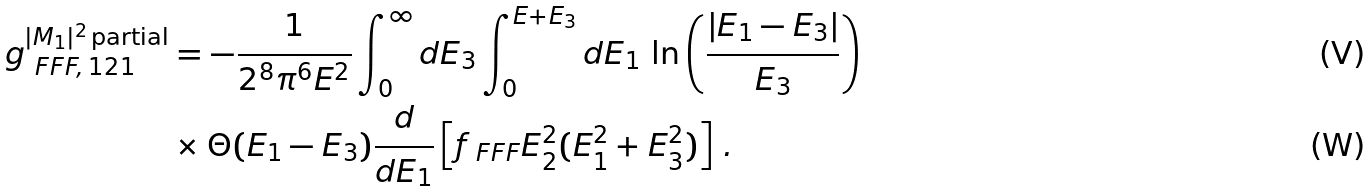Convert formula to latex. <formula><loc_0><loc_0><loc_500><loc_500>g _ { \ F F F , \, 1 2 1 } ^ { | M _ { 1 } | ^ { 2 } \, \text {partial} } & = - \frac { 1 } { 2 ^ { 8 } \pi ^ { 6 } E ^ { 2 } } \int _ { 0 } ^ { \infty } d E _ { 3 } \int _ { 0 } ^ { E + E _ { 3 } } d E _ { 1 } \, \ln \left ( \frac { | E _ { 1 } - E _ { 3 } | } { E _ { 3 } } \right ) \\ & \times \Theta ( E _ { 1 } - E _ { 3 } ) \frac { d } { d E _ { 1 } } \left [ f _ { \ F F F } E _ { 2 } ^ { 2 } ( E _ { 1 } ^ { 2 } + E _ { 3 } ^ { 2 } ) \right ] \, .</formula> 